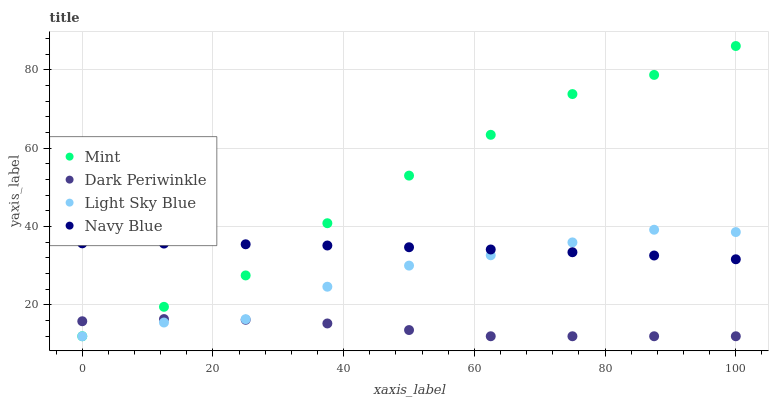Does Dark Periwinkle have the minimum area under the curve?
Answer yes or no. Yes. Does Mint have the maximum area under the curve?
Answer yes or no. Yes. Does Light Sky Blue have the minimum area under the curve?
Answer yes or no. No. Does Light Sky Blue have the maximum area under the curve?
Answer yes or no. No. Is Navy Blue the smoothest?
Answer yes or no. Yes. Is Light Sky Blue the roughest?
Answer yes or no. Yes. Is Mint the smoothest?
Answer yes or no. No. Is Mint the roughest?
Answer yes or no. No. Does Light Sky Blue have the lowest value?
Answer yes or no. Yes. Does Mint have the highest value?
Answer yes or no. Yes. Does Light Sky Blue have the highest value?
Answer yes or no. No. Is Dark Periwinkle less than Navy Blue?
Answer yes or no. Yes. Is Navy Blue greater than Dark Periwinkle?
Answer yes or no. Yes. Does Navy Blue intersect Light Sky Blue?
Answer yes or no. Yes. Is Navy Blue less than Light Sky Blue?
Answer yes or no. No. Is Navy Blue greater than Light Sky Blue?
Answer yes or no. No. Does Dark Periwinkle intersect Navy Blue?
Answer yes or no. No. 